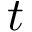<formula> <loc_0><loc_0><loc_500><loc_500>t</formula> 